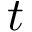<formula> <loc_0><loc_0><loc_500><loc_500>t</formula> 